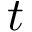<formula> <loc_0><loc_0><loc_500><loc_500>t</formula> 